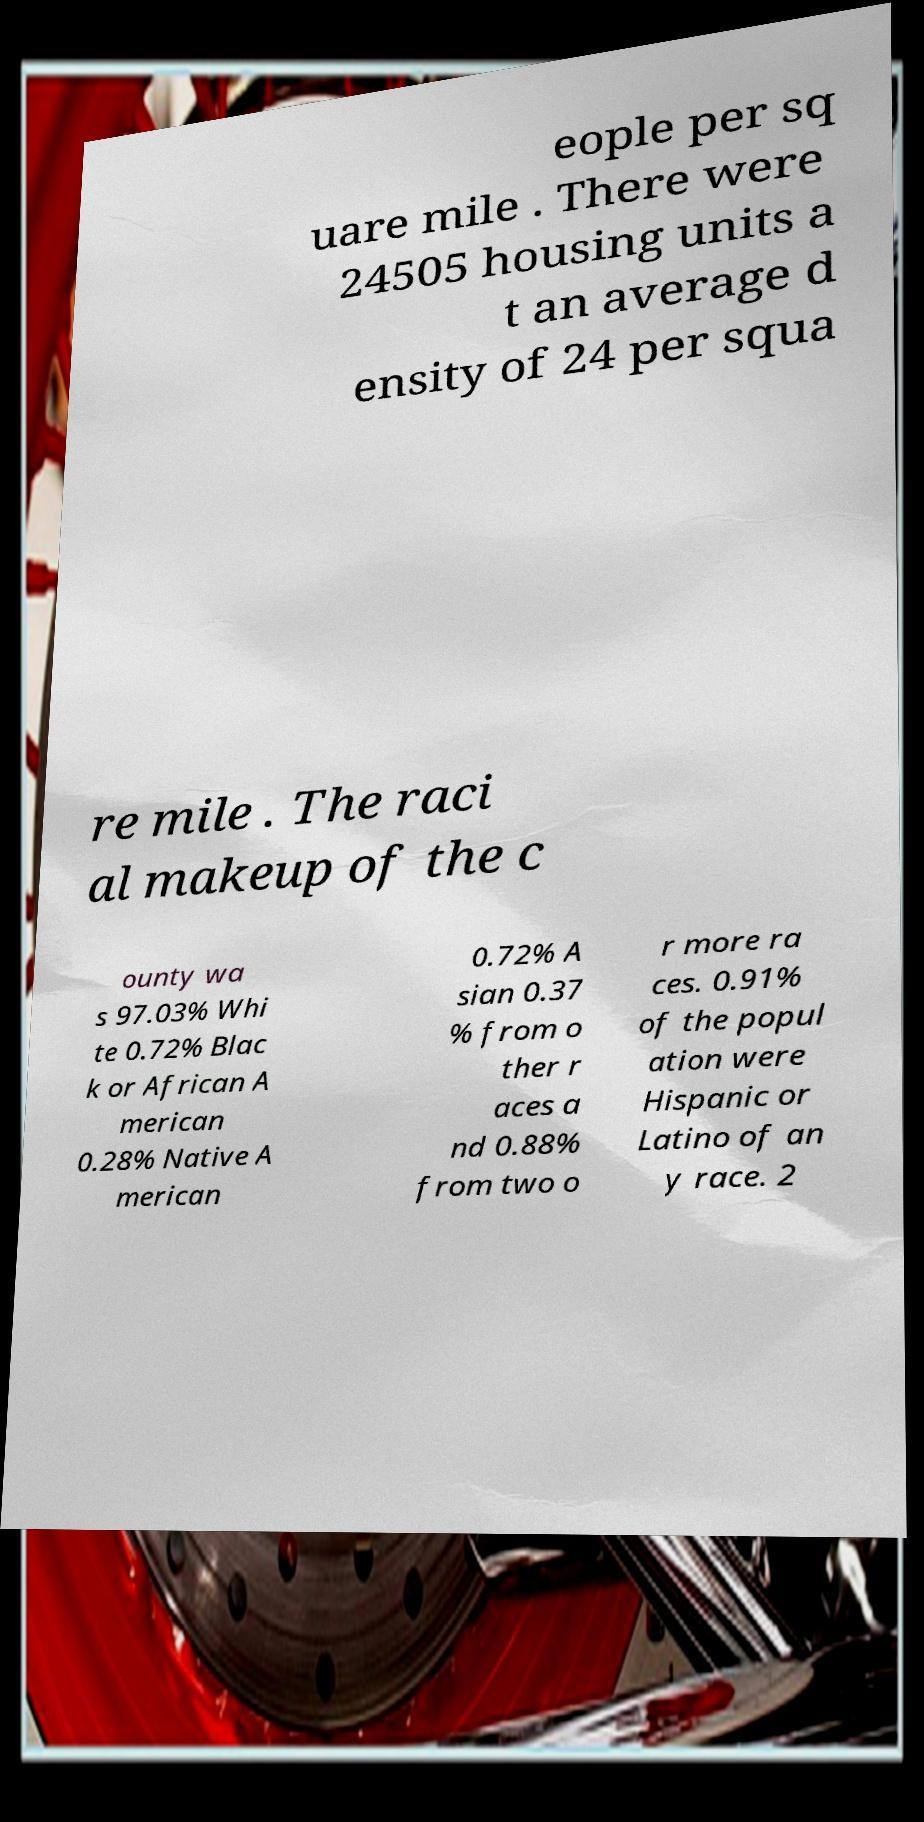What messages or text are displayed in this image? I need them in a readable, typed format. eople per sq uare mile . There were 24505 housing units a t an average d ensity of 24 per squa re mile . The raci al makeup of the c ounty wa s 97.03% Whi te 0.72% Blac k or African A merican 0.28% Native A merican 0.72% A sian 0.37 % from o ther r aces a nd 0.88% from two o r more ra ces. 0.91% of the popul ation were Hispanic or Latino of an y race. 2 